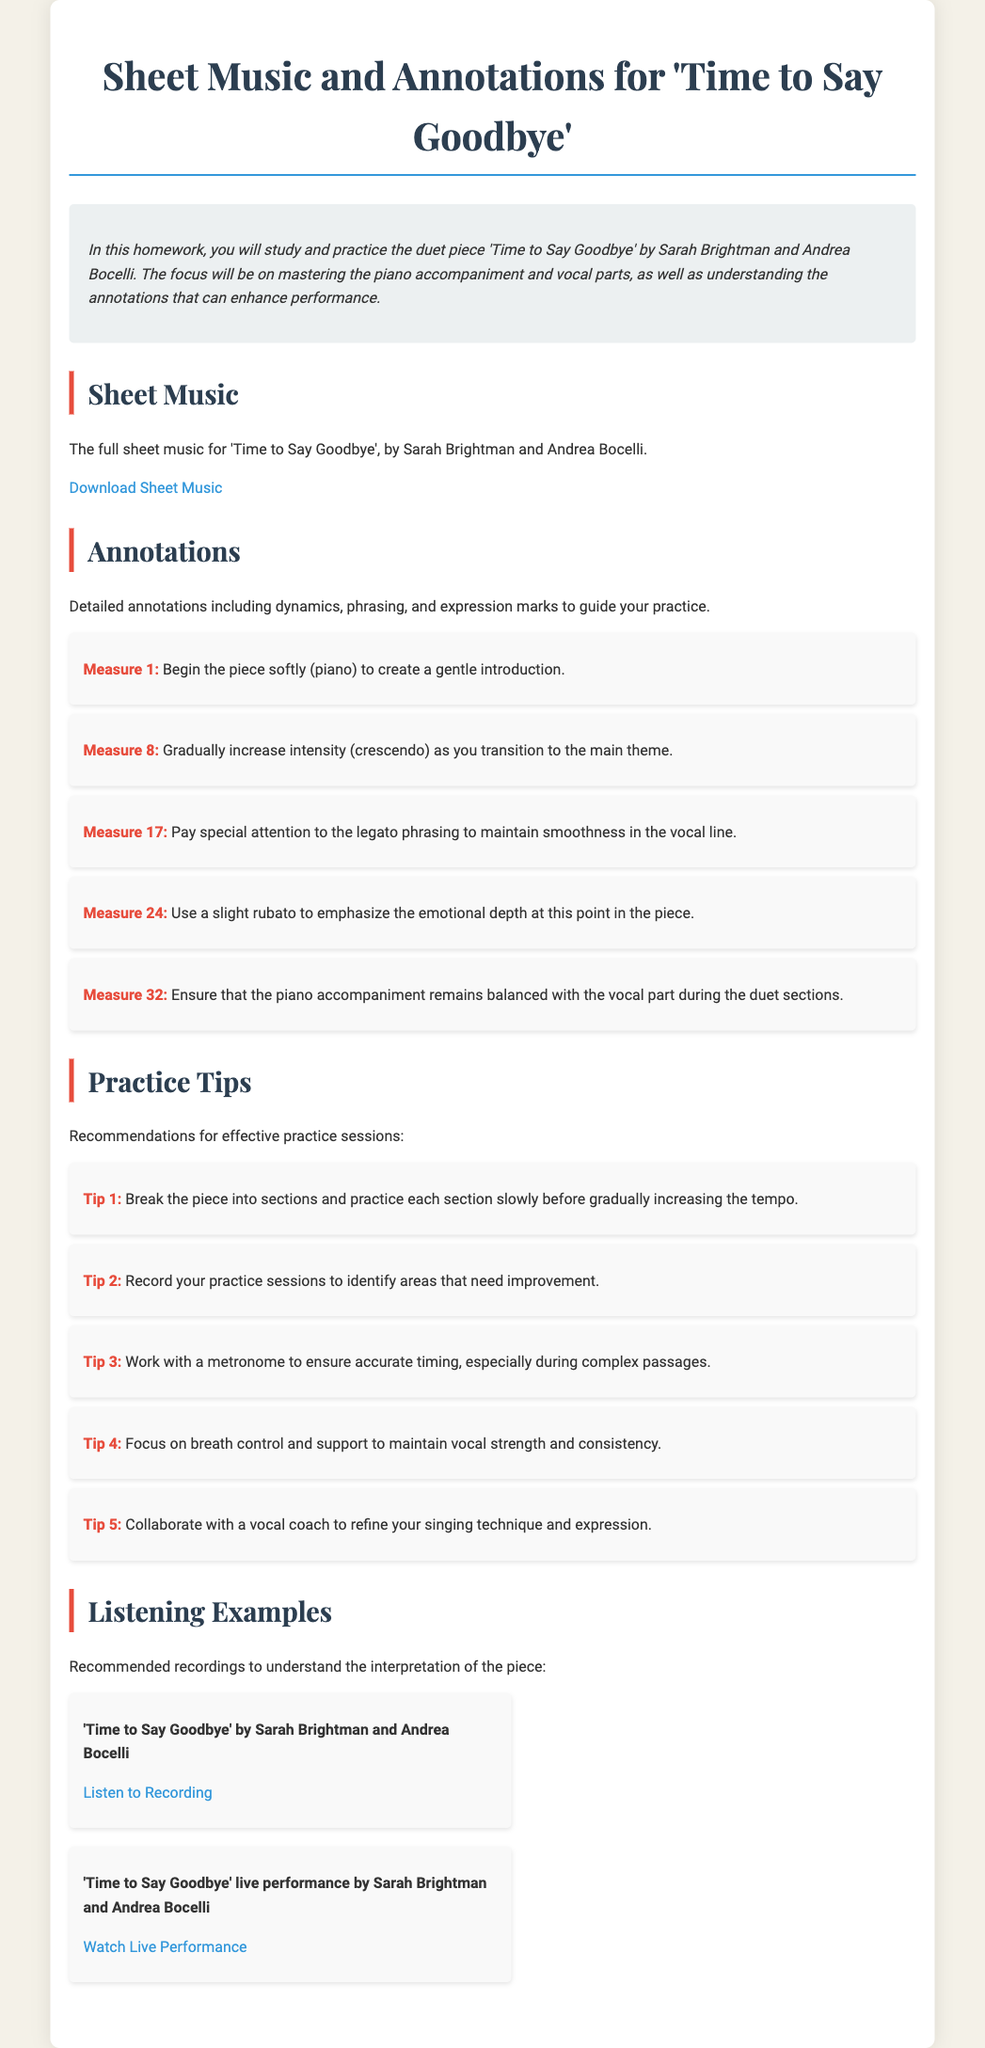What is the title of the duet piece? The title is mentioned in the document as 'Time to Say Goodbye'.
Answer: Time to Say Goodbye Who are the artists of the duet piece? The artists are specified in the document as Sarah Brightman and Andrea Bocelli.
Answer: Sarah Brightman and Andrea Bocelli Which measure suggests a gradual increase in intensity? The specific measure is mentioned in the annotations section of the document, referring to increase intensity.
Answer: Measure 8 What is the first practice tip mentioned in the document? The first practice tip is clearly listed in the practice tips section of the document.
Answer: Break the piece into sections and practice each section slowly before gradually increasing the tempo What does the document recommend to ensure accurate timing? This recommendation is found under practice tips and encourages a specific tool for maintaining timing.
Answer: Work with a metronome How many listening examples are provided? The number of listening examples can be easily counted in the relevant section of the document.
Answer: Two 